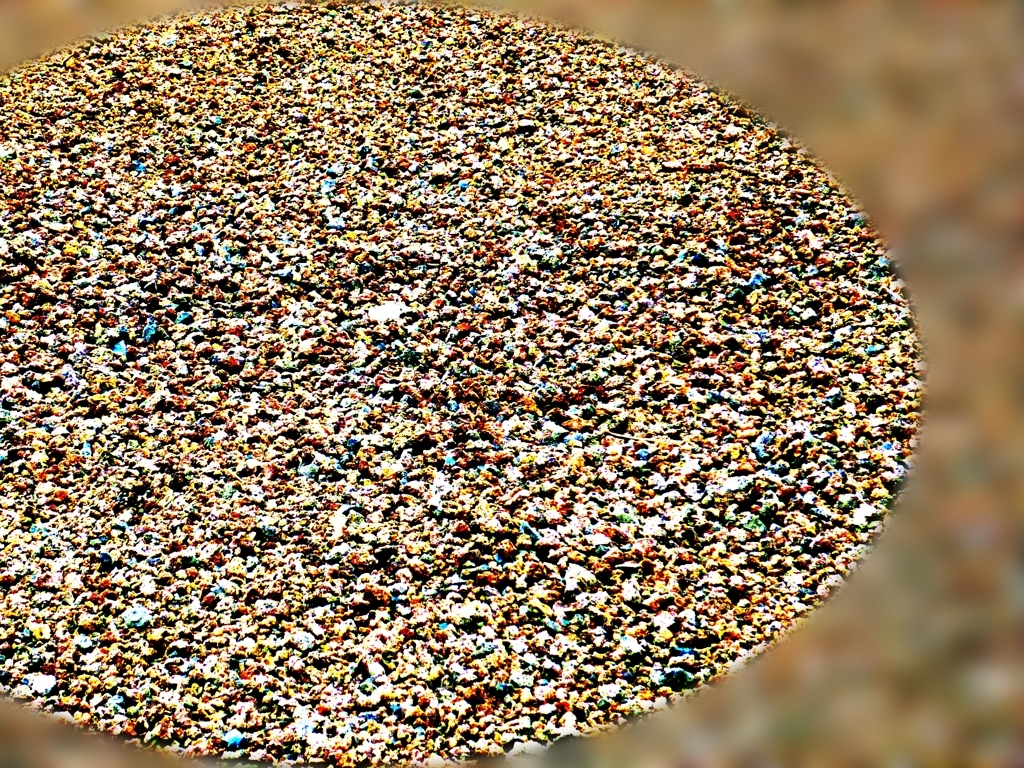What emotions does this image evoke? The image evokes a sense of liveliness and energy, thanks to the varied and vivid colors. It may also inspire a sense of wonder or intrigue as viewers might try to discern the pattern or figure out what the image represents. 